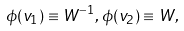Convert formula to latex. <formula><loc_0><loc_0><loc_500><loc_500>\phi ( v _ { 1 } ) \equiv W ^ { - 1 } , \, \phi ( v _ { 2 } ) \equiv W ,</formula> 